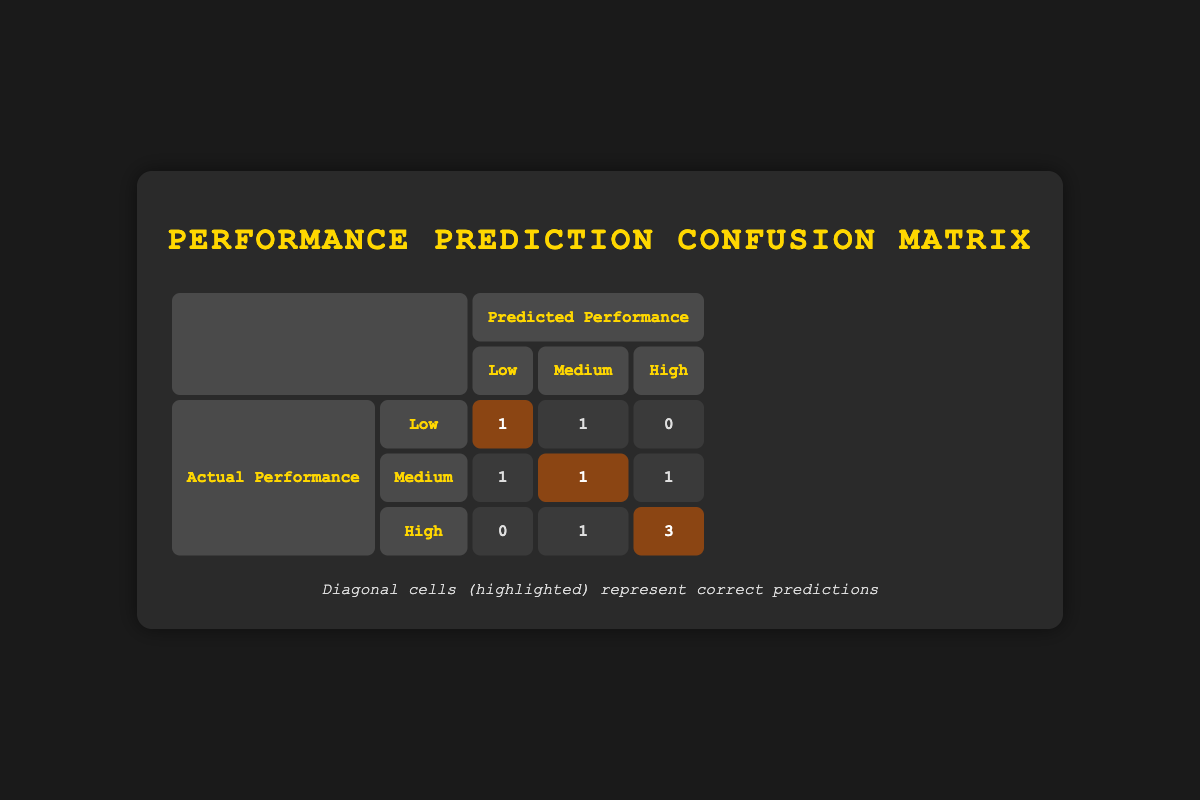What is the total number of correct predictions? The correct predictions are represented by the diagonal cells in the confusion matrix. Adding those values: 1 (Low, Low) + 1 (Medium, Medium) + 3 (High, High) = 5.
Answer: 5 How many times was the performance predicted as High when it was actually Medium? In the table, we can see that there is 1 instance where the actual performance is Medium and the predicted performance is High. Therefore, the answer is 1.
Answer: 1 What is the number of instances where the performance was predicted as Low? We will look at the "Predicted Performance" column for Low, counting the occurrences: 1 (Actual Low) + 1 (Actual Medium) + 0 (Actual High) = 2.
Answer: 2 Was there any instance where the equipment was predicted to have Low performance but actually had High performance? Looking through the matrix, there are no occurrences where 'Low' was predicted while 'High' was actual, thus the answer is no.
Answer: No Which predicted performance level has the highest number of correct predictions? By comparing the diagonal values: (Low, Low) is 1, (Medium, Medium) is 1, and (High, High) is 3. The highest is 3 for High. Therefore, the highest number of correct predictions is at the High level.
Answer: High 